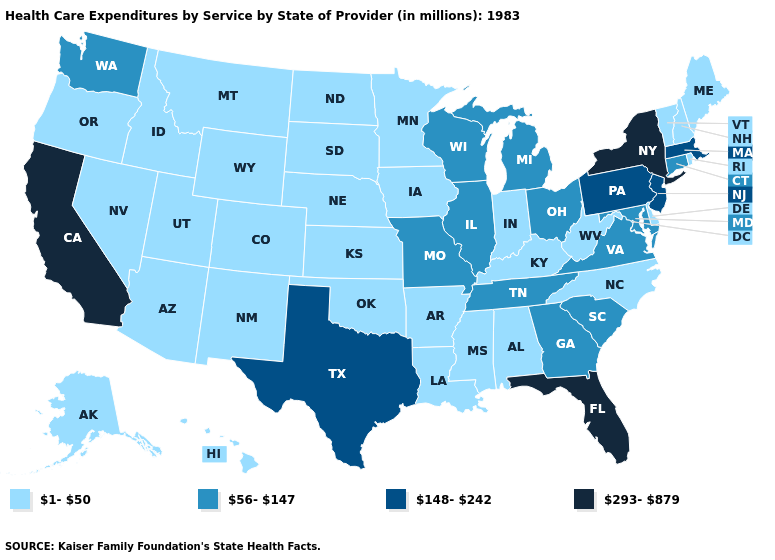Name the states that have a value in the range 56-147?
Write a very short answer. Connecticut, Georgia, Illinois, Maryland, Michigan, Missouri, Ohio, South Carolina, Tennessee, Virginia, Washington, Wisconsin. Does Florida have the lowest value in the USA?
Keep it brief. No. Name the states that have a value in the range 56-147?
Short answer required. Connecticut, Georgia, Illinois, Maryland, Michigan, Missouri, Ohio, South Carolina, Tennessee, Virginia, Washington, Wisconsin. Name the states that have a value in the range 293-879?
Write a very short answer. California, Florida, New York. Name the states that have a value in the range 293-879?
Give a very brief answer. California, Florida, New York. Name the states that have a value in the range 293-879?
Short answer required. California, Florida, New York. Does South Carolina have the highest value in the South?
Answer briefly. No. What is the lowest value in states that border Michigan?
Be succinct. 1-50. Does Maine have the lowest value in the Northeast?
Keep it brief. Yes. Name the states that have a value in the range 56-147?
Write a very short answer. Connecticut, Georgia, Illinois, Maryland, Michigan, Missouri, Ohio, South Carolina, Tennessee, Virginia, Washington, Wisconsin. Does the map have missing data?
Give a very brief answer. No. Does South Carolina have the lowest value in the USA?
Quick response, please. No. Which states have the lowest value in the MidWest?
Be succinct. Indiana, Iowa, Kansas, Minnesota, Nebraska, North Dakota, South Dakota. Name the states that have a value in the range 148-242?
Quick response, please. Massachusetts, New Jersey, Pennsylvania, Texas. Name the states that have a value in the range 293-879?
Quick response, please. California, Florida, New York. 